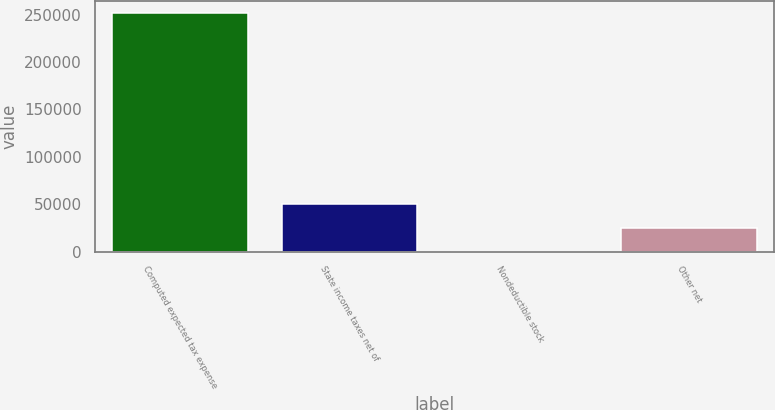<chart> <loc_0><loc_0><loc_500><loc_500><bar_chart><fcel>Computed expected tax expense<fcel>State income taxes net of<fcel>Nondeductible stock<fcel>Other net<nl><fcel>251508<fcel>50352<fcel>63<fcel>25207.5<nl></chart> 